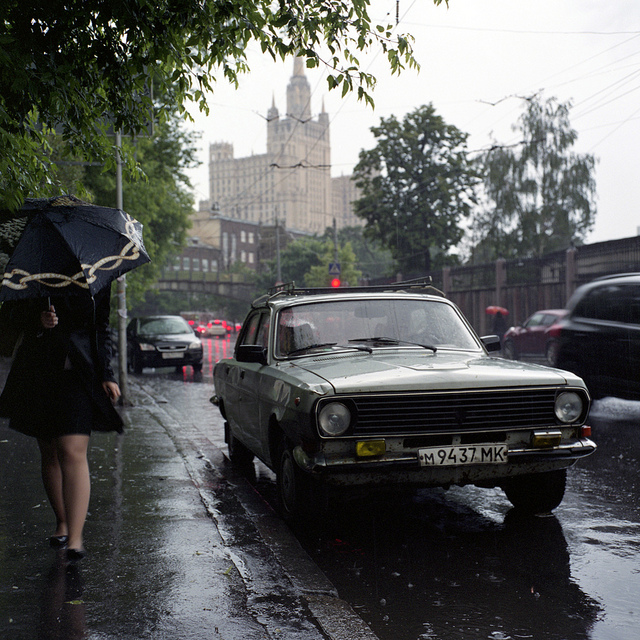Identify the text contained in this image. M 9437 MK 